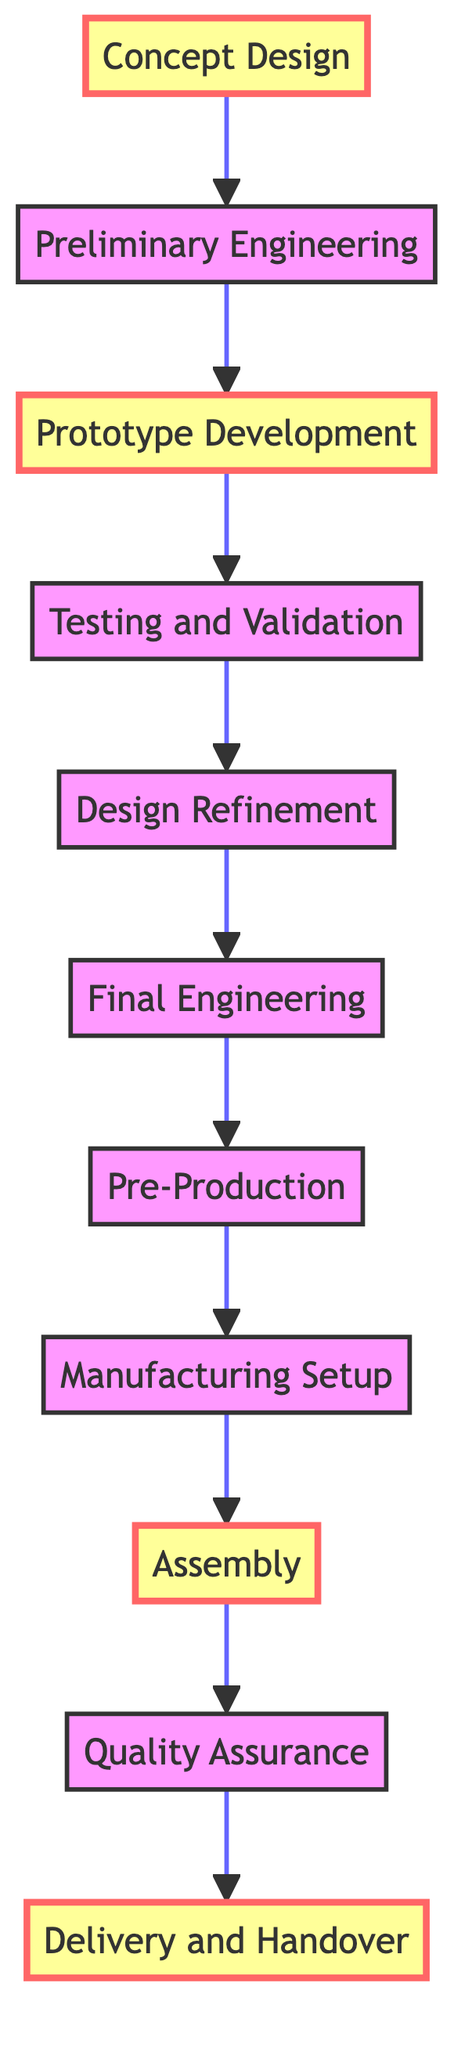What is the first step in the production timeline? The diagram indicates that the first step in the production timeline is "Concept Design," which is visually positioned at the start of the flow.
Answer: Concept Design How many major steps are there in the production timeline? By counting the steps presented in the diagram from Concept Design to Delivery and Handover, there are a total of 11 steps.
Answer: 11 Which step comes after "Prototype Development"? According to the flow in the diagram, the step that directly follows "Prototype Development" is "Testing and Validation," as indicated by the arrows connecting the nodes.
Answer: Testing and Validation What is the last step before "Delivery and Handover"? The step leading directly to "Delivery and Handover" in the production timeline is "Quality Assurance," as the diagram shows this sequence clearly with an arrow.
Answer: Quality Assurance How many milestone steps are indicated in the diagram? The diagram highlights three milestone steps, which are marked in a different color and include "Concept Design," "Prototype Development," and "Assembly."
Answer: 3 What is done during the "Design Refinement" step? The description within the diagram states that during "Design Refinement," necessary adjustments are made based on the test results from the previous step.
Answer: Adjustments based on test results Which step involves rigorous testing of the prototype? The diagram clearly states that "Testing and Validation" is the step where the prototype undergoes rigorous testing, including performance and safety assessments.
Answer: Testing and Validation What happens in the "Manufacturing Setup" phase? In "Manufacturing Setup," the diagram indicates that manufacturing facilities are prepared and production lines are configured, essential for the next steps.
Answer: Facilities are prepared and production lines configured Describe the primary focus of the "Final Engineering" step. The diagram outlines that "Final Engineering" encompasses comprehensive engineering of all components including powertrain, chassis, and electronics, ensuring everything is ready for production.
Answer: Engineering of all components 